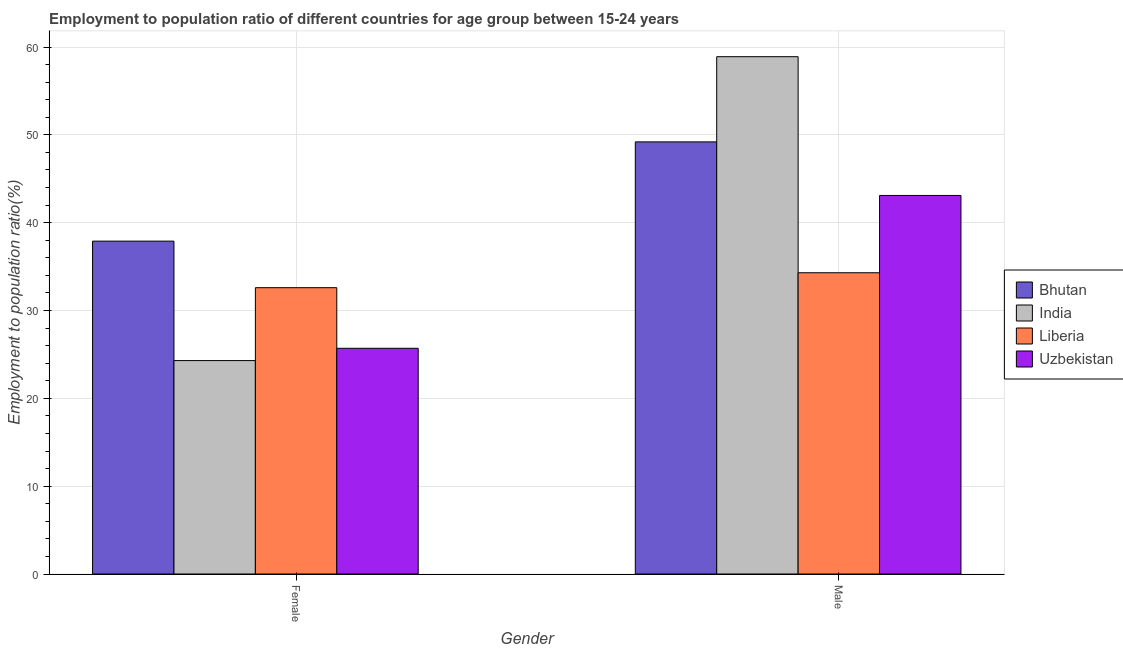How many groups of bars are there?
Your answer should be very brief. 2. Are the number of bars per tick equal to the number of legend labels?
Offer a terse response. Yes. What is the label of the 1st group of bars from the left?
Offer a terse response. Female. What is the employment to population ratio(male) in Liberia?
Keep it short and to the point. 34.3. Across all countries, what is the maximum employment to population ratio(male)?
Ensure brevity in your answer.  58.9. Across all countries, what is the minimum employment to population ratio(female)?
Make the answer very short. 24.3. In which country was the employment to population ratio(female) maximum?
Offer a very short reply. Bhutan. In which country was the employment to population ratio(male) minimum?
Make the answer very short. Liberia. What is the total employment to population ratio(female) in the graph?
Ensure brevity in your answer.  120.5. What is the difference between the employment to population ratio(male) in Liberia and that in Uzbekistan?
Offer a very short reply. -8.8. What is the difference between the employment to population ratio(female) in Liberia and the employment to population ratio(male) in Bhutan?
Your answer should be compact. -16.6. What is the average employment to population ratio(male) per country?
Provide a short and direct response. 46.38. What is the difference between the employment to population ratio(female) and employment to population ratio(male) in Bhutan?
Your response must be concise. -11.3. What is the ratio of the employment to population ratio(male) in Bhutan to that in Uzbekistan?
Your answer should be very brief. 1.14. Is the employment to population ratio(male) in Liberia less than that in India?
Your answer should be compact. Yes. In how many countries, is the employment to population ratio(male) greater than the average employment to population ratio(male) taken over all countries?
Ensure brevity in your answer.  2. What does the 2nd bar from the left in Female represents?
Ensure brevity in your answer.  India. What does the 4th bar from the right in Male represents?
Keep it short and to the point. Bhutan. How many bars are there?
Provide a short and direct response. 8. Are all the bars in the graph horizontal?
Give a very brief answer. No. Does the graph contain grids?
Provide a succinct answer. Yes. What is the title of the graph?
Your response must be concise. Employment to population ratio of different countries for age group between 15-24 years. Does "Indonesia" appear as one of the legend labels in the graph?
Give a very brief answer. No. What is the label or title of the Y-axis?
Offer a terse response. Employment to population ratio(%). What is the Employment to population ratio(%) of Bhutan in Female?
Make the answer very short. 37.9. What is the Employment to population ratio(%) in India in Female?
Your response must be concise. 24.3. What is the Employment to population ratio(%) in Liberia in Female?
Give a very brief answer. 32.6. What is the Employment to population ratio(%) of Uzbekistan in Female?
Offer a terse response. 25.7. What is the Employment to population ratio(%) of Bhutan in Male?
Your response must be concise. 49.2. What is the Employment to population ratio(%) in India in Male?
Offer a very short reply. 58.9. What is the Employment to population ratio(%) in Liberia in Male?
Offer a terse response. 34.3. What is the Employment to population ratio(%) of Uzbekistan in Male?
Your answer should be very brief. 43.1. Across all Gender, what is the maximum Employment to population ratio(%) of Bhutan?
Make the answer very short. 49.2. Across all Gender, what is the maximum Employment to population ratio(%) in India?
Your response must be concise. 58.9. Across all Gender, what is the maximum Employment to population ratio(%) of Liberia?
Your answer should be very brief. 34.3. Across all Gender, what is the maximum Employment to population ratio(%) of Uzbekistan?
Your answer should be very brief. 43.1. Across all Gender, what is the minimum Employment to population ratio(%) of Bhutan?
Keep it short and to the point. 37.9. Across all Gender, what is the minimum Employment to population ratio(%) in India?
Provide a succinct answer. 24.3. Across all Gender, what is the minimum Employment to population ratio(%) in Liberia?
Your answer should be very brief. 32.6. Across all Gender, what is the minimum Employment to population ratio(%) in Uzbekistan?
Your answer should be very brief. 25.7. What is the total Employment to population ratio(%) in Bhutan in the graph?
Provide a succinct answer. 87.1. What is the total Employment to population ratio(%) in India in the graph?
Provide a succinct answer. 83.2. What is the total Employment to population ratio(%) of Liberia in the graph?
Provide a short and direct response. 66.9. What is the total Employment to population ratio(%) of Uzbekistan in the graph?
Offer a terse response. 68.8. What is the difference between the Employment to population ratio(%) in India in Female and that in Male?
Provide a short and direct response. -34.6. What is the difference between the Employment to population ratio(%) of Uzbekistan in Female and that in Male?
Your answer should be compact. -17.4. What is the difference between the Employment to population ratio(%) in Bhutan in Female and the Employment to population ratio(%) in India in Male?
Your answer should be compact. -21. What is the difference between the Employment to population ratio(%) of Bhutan in Female and the Employment to population ratio(%) of Uzbekistan in Male?
Provide a short and direct response. -5.2. What is the difference between the Employment to population ratio(%) in India in Female and the Employment to population ratio(%) in Uzbekistan in Male?
Keep it short and to the point. -18.8. What is the average Employment to population ratio(%) in Bhutan per Gender?
Your answer should be compact. 43.55. What is the average Employment to population ratio(%) in India per Gender?
Your response must be concise. 41.6. What is the average Employment to population ratio(%) of Liberia per Gender?
Provide a succinct answer. 33.45. What is the average Employment to population ratio(%) of Uzbekistan per Gender?
Offer a very short reply. 34.4. What is the difference between the Employment to population ratio(%) of Bhutan and Employment to population ratio(%) of Uzbekistan in Female?
Make the answer very short. 12.2. What is the difference between the Employment to population ratio(%) of India and Employment to population ratio(%) of Uzbekistan in Female?
Your answer should be very brief. -1.4. What is the difference between the Employment to population ratio(%) in Bhutan and Employment to population ratio(%) in India in Male?
Provide a short and direct response. -9.7. What is the difference between the Employment to population ratio(%) of India and Employment to population ratio(%) of Liberia in Male?
Keep it short and to the point. 24.6. What is the ratio of the Employment to population ratio(%) of Bhutan in Female to that in Male?
Your answer should be compact. 0.77. What is the ratio of the Employment to population ratio(%) in India in Female to that in Male?
Provide a short and direct response. 0.41. What is the ratio of the Employment to population ratio(%) in Liberia in Female to that in Male?
Provide a short and direct response. 0.95. What is the ratio of the Employment to population ratio(%) of Uzbekistan in Female to that in Male?
Your response must be concise. 0.6. What is the difference between the highest and the second highest Employment to population ratio(%) in India?
Provide a short and direct response. 34.6. What is the difference between the highest and the lowest Employment to population ratio(%) of India?
Your answer should be compact. 34.6. What is the difference between the highest and the lowest Employment to population ratio(%) in Liberia?
Your answer should be very brief. 1.7. What is the difference between the highest and the lowest Employment to population ratio(%) of Uzbekistan?
Your response must be concise. 17.4. 